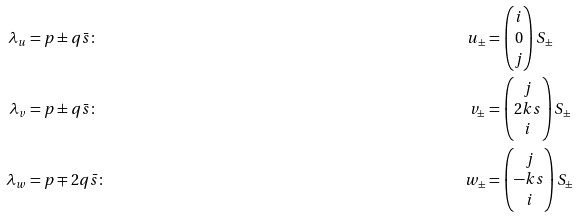<formula> <loc_0><loc_0><loc_500><loc_500>\lambda _ { u } & = p \pm q \bar { s } \colon & u _ { \pm } & = \begin{pmatrix} i \\ 0 \\ j \end{pmatrix} S _ { \pm } \\ \lambda _ { v } & = p \pm q \bar { s } \colon & v _ { \pm } & = \begin{pmatrix} j \\ 2 k s \\ i \end{pmatrix} S _ { \pm } \\ \lambda _ { w } & = p \mp 2 q \bar { s } \colon & w _ { \pm } & = \begin{pmatrix} j \\ - k s \\ i \end{pmatrix} S _ { \pm }</formula> 